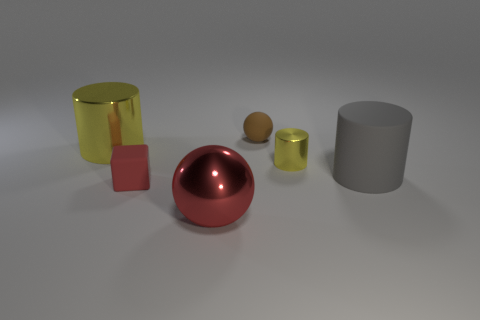Subtract all yellow spheres. Subtract all red cylinders. How many spheres are left? 2 Add 4 tiny yellow things. How many objects exist? 10 Subtract all spheres. How many objects are left? 4 Add 2 balls. How many balls exist? 4 Subtract 0 gray balls. How many objects are left? 6 Subtract all tiny rubber objects. Subtract all tiny red rubber cubes. How many objects are left? 3 Add 6 gray rubber things. How many gray rubber things are left? 7 